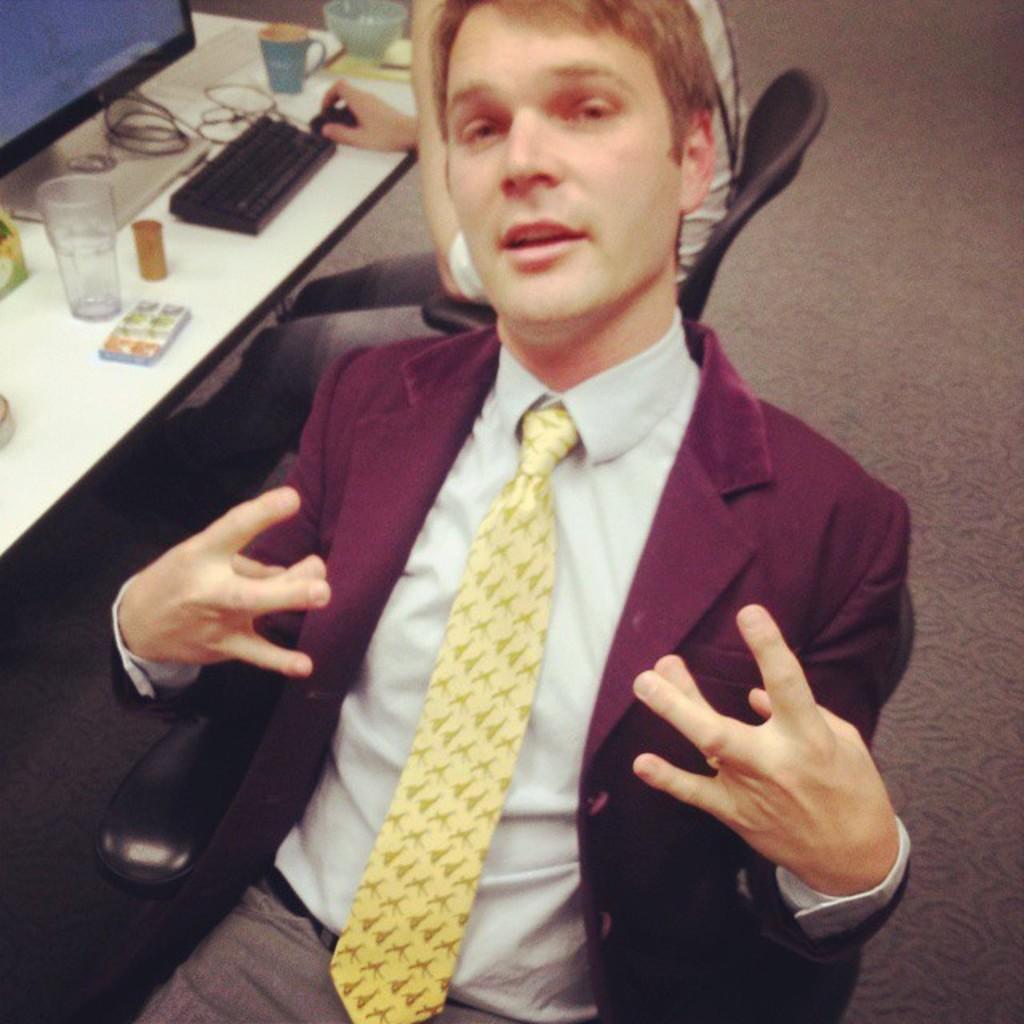Describe this image in one or two sentences. In this image, we can see people sitting on the chairs and one of them is wearing a coat and a tie and we can see a system, keyboard and a mouse, a cup, glass and some other objects on the table. At the bottom, there is a floor. 